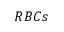<formula> <loc_0><loc_0><loc_500><loc_500>R B C s</formula> 